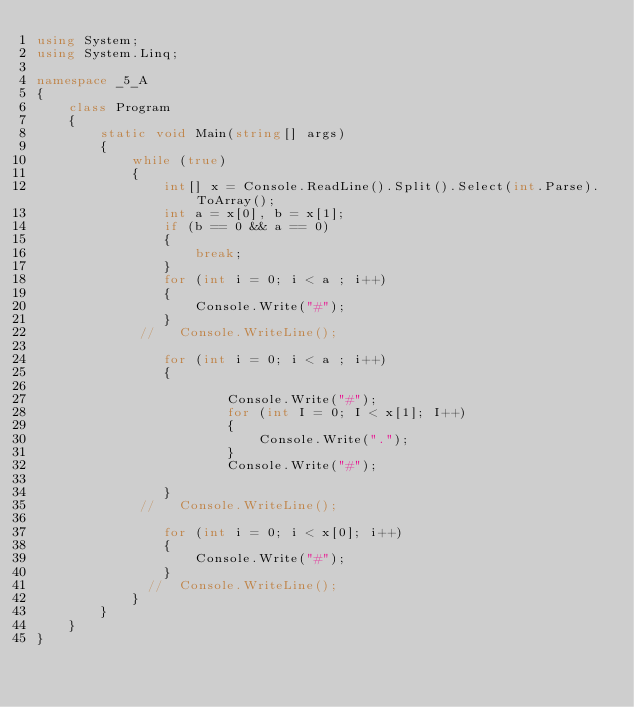<code> <loc_0><loc_0><loc_500><loc_500><_C#_>using System;
using System.Linq;

namespace _5_A
{
    class Program
    {
        static void Main(string[] args)
        {
            while (true)
            {
                int[] x = Console.ReadLine().Split().Select(int.Parse).ToArray();
                int a = x[0], b = x[1];
                if (b == 0 && a == 0)
                {
                    break;
                }
                for (int i = 0; i < a ; i++)
                {
                    Console.Write("#"); 
                }
             //   Console.WriteLine();

                for (int i = 0; i < a ; i++)
                {
                    
                        Console.Write("#");
                        for (int I = 0; I < x[1]; I++)
                        {
                            Console.Write(".");
                        }
                        Console.Write("#");

                }
             //   Console.WriteLine();

                for (int i = 0; i < x[0]; i++)
                {
                    Console.Write("#");
                }
              //  Console.WriteLine();
            }
        }
    }
}</code> 